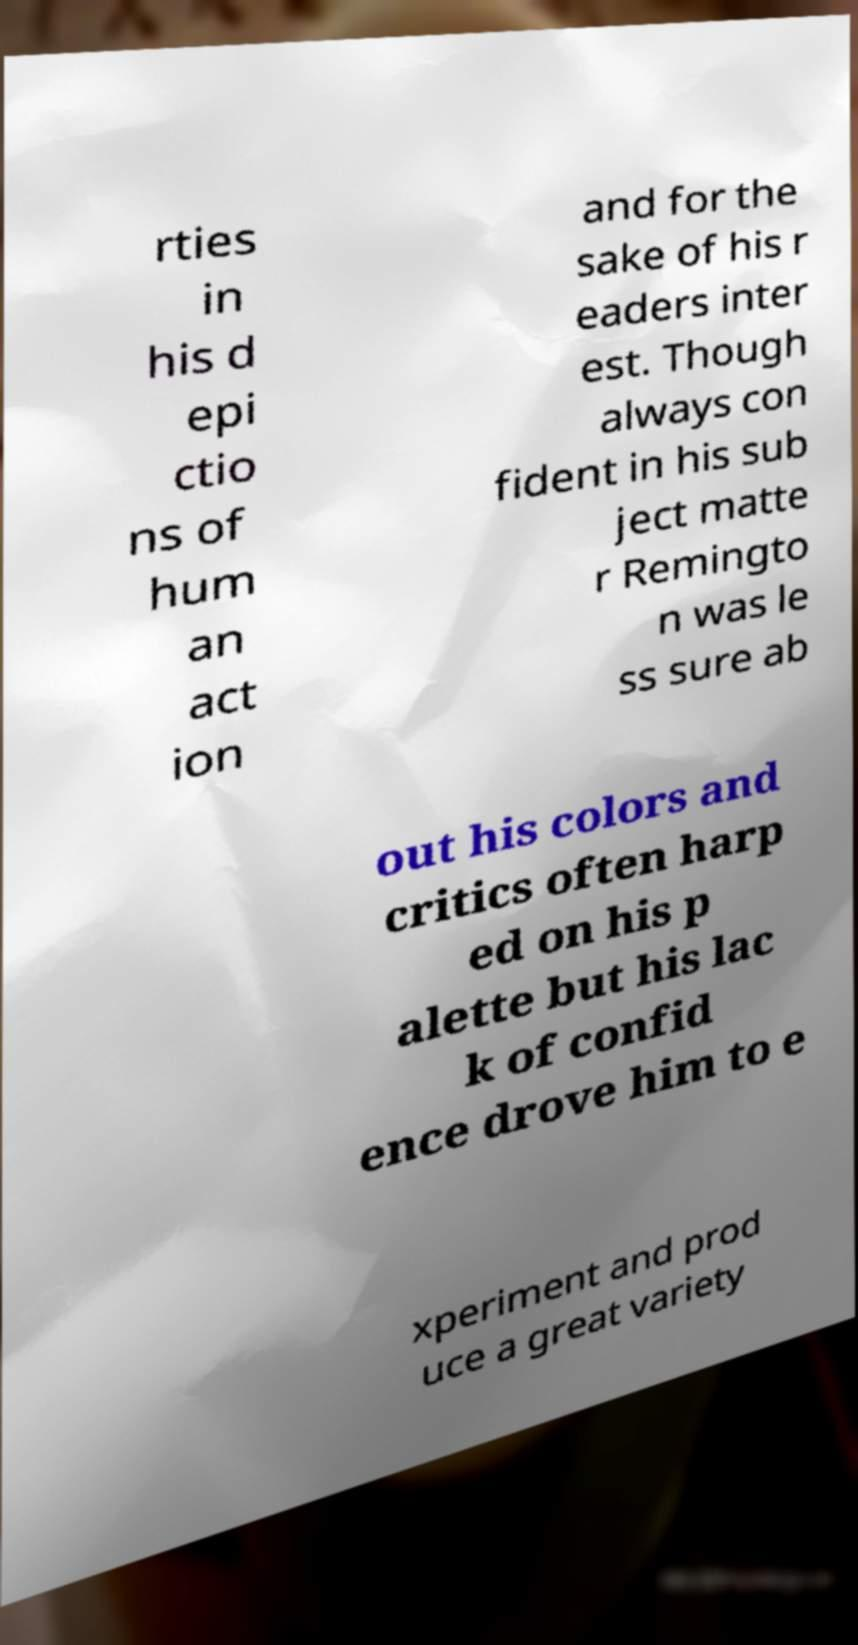What messages or text are displayed in this image? I need them in a readable, typed format. rties in his d epi ctio ns of hum an act ion and for the sake of his r eaders inter est. Though always con fident in his sub ject matte r Remingto n was le ss sure ab out his colors and critics often harp ed on his p alette but his lac k of confid ence drove him to e xperiment and prod uce a great variety 